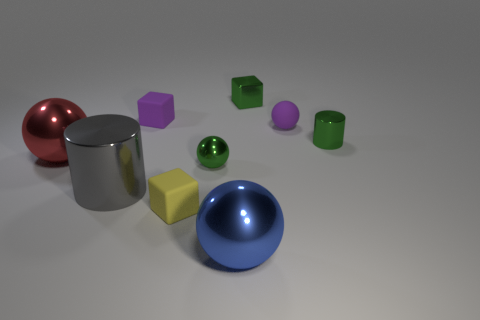There is a cylinder that is on the left side of the blue shiny ball; what is its size?
Keep it short and to the point. Large. Is the shape of the gray object the same as the red object?
Keep it short and to the point. No. How many tiny objects are purple blocks or green cubes?
Provide a succinct answer. 2. Are there any blocks in front of the gray object?
Provide a short and direct response. Yes. Are there an equal number of green metallic blocks that are on the left side of the rubber ball and large objects?
Your response must be concise. No. What is the size of the blue shiny object that is the same shape as the red shiny object?
Provide a succinct answer. Large. Is the shape of the blue object the same as the red object behind the yellow rubber cube?
Your answer should be very brief. Yes. There is a green shiny thing that is in front of the metal sphere that is to the left of the large gray thing; what is its size?
Offer a very short reply. Small. Are there an equal number of yellow rubber things that are on the right side of the yellow matte object and small matte spheres that are on the left side of the small green metal block?
Provide a succinct answer. Yes. What is the color of the tiny matte object that is the same shape as the large blue shiny thing?
Keep it short and to the point. Purple. 